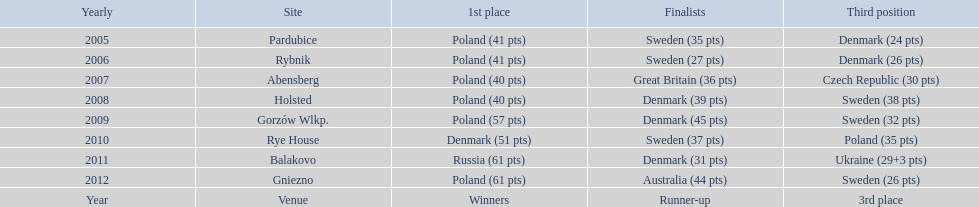Which team has the most third place wins in the speedway junior world championship between 2005 and 2012? Sweden. 